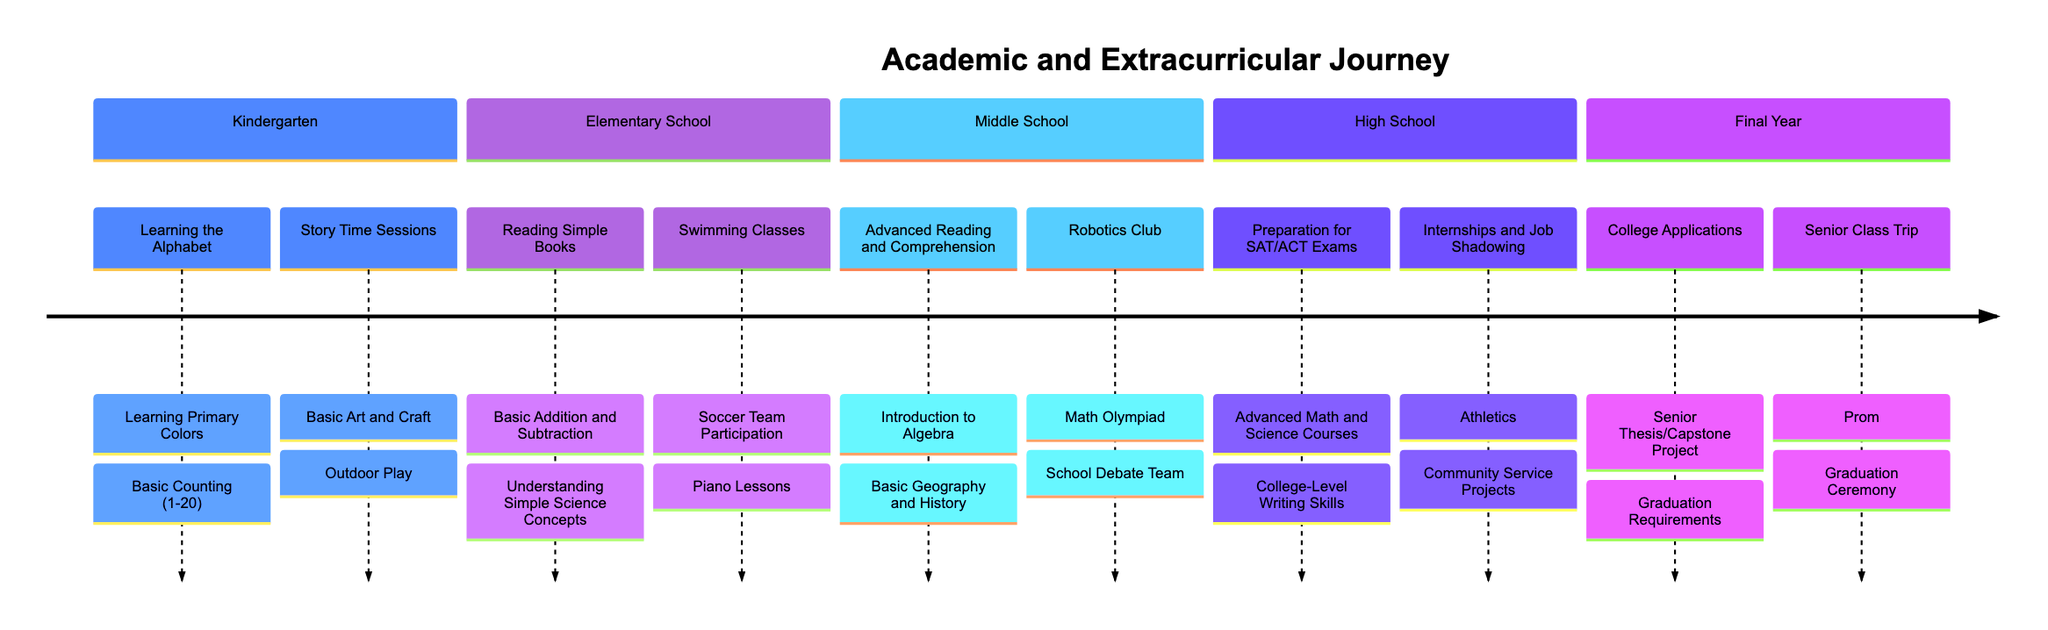What are the academic milestones in Kindergarten? In the Kindergarten section of the timeline, the academic milestones listed are: Learning the Alphabet, Basic Counting (1-20), Learning Primary Colors, and Introduction to Reading Comprehension. These milestones are the specific educational targets for this stage.
Answer: Learning the Alphabet, Basic Counting (1-20), Learning Primary Colors, Introduction to Reading Comprehension What extracurricular activities are available in Middle School? The Middle School section of the timeline lists the extracurricular activities as Robotics Club, Math Olympiad, Art Classes, and School Debate Team. This indicates the options available for students to engage outside their regular academic curriculum at this stage.
Answer: Robotics Club, Math Olympiad, Art Classes, School Debate Team How many academic milestones are listed for High School? In the High School section, there are four academic milestones listed: Preparation for SAT/ACT Exams, Advanced Math and Science Courses, College-Level Writing Skills, and Critical Thinking and Analysis. To determine the number, we simply count the listed milestones.
Answer: 4 Which extracurricular activity is related to community involvement in High School? The High School section mentions Community Service Projects as one of the extracurricular activities, which directly relates to community involvement, highlighting a way for students to contribute positively to their communities.
Answer: Community Service Projects What is the final academic milestone before graduation? In the Final Year section, the last academic milestone is Financial Literacy Education. This milestone is crucial for preparing students for real-life financial responsibilities, marking a significant step before they graduate.
Answer: Financial Literacy Education How many sections are there in the timeline? The timeline includes five sections: Kindergarten, Elementary School (Grades 1-5), Middle School (Grades 6-8), High School (Grades 9-12), and Final Year. By counting each distinct segment, we can determine the total sections.
Answer: 5 Which year includes senior activities like prom and graduation ceremony? The Final Year section of the timeline clearly outlines activities such as Prom and Graduation Ceremony. These events are significant milestones that occur during the last year of high school, leading up to graduation.
Answer: Final Year What is one academic milestone that is introduced in Elementary School? In the Elementary School section, one of the academic milestones introduced is Introduction to Writing Paragraphs. This reflects a progression in writing skills that typically occurs during this stage of education.
Answer: Introduction to Writing Paragraphs 